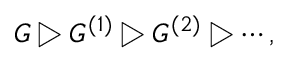<formula> <loc_0><loc_0><loc_500><loc_500>G \triangleright G ^ { ( 1 ) } \triangleright G ^ { ( 2 ) } \triangleright \cdots ,</formula> 